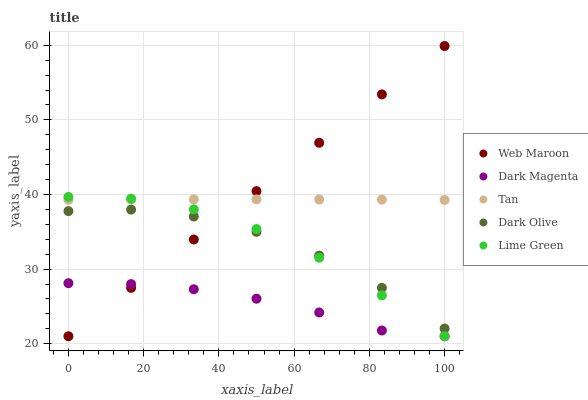Does Dark Magenta have the minimum area under the curve?
Answer yes or no. Yes. Does Web Maroon have the maximum area under the curve?
Answer yes or no. Yes. Does Tan have the minimum area under the curve?
Answer yes or no. No. Does Tan have the maximum area under the curve?
Answer yes or no. No. Is Web Maroon the smoothest?
Answer yes or no. Yes. Is Dark Olive the roughest?
Answer yes or no. Yes. Is Tan the smoothest?
Answer yes or no. No. Is Tan the roughest?
Answer yes or no. No. Does Lime Green have the lowest value?
Answer yes or no. Yes. Does Dark Olive have the lowest value?
Answer yes or no. No. Does Web Maroon have the highest value?
Answer yes or no. Yes. Does Tan have the highest value?
Answer yes or no. No. Is Dark Magenta less than Tan?
Answer yes or no. Yes. Is Tan greater than Dark Magenta?
Answer yes or no. Yes. Does Lime Green intersect Tan?
Answer yes or no. Yes. Is Lime Green less than Tan?
Answer yes or no. No. Is Lime Green greater than Tan?
Answer yes or no. No. Does Dark Magenta intersect Tan?
Answer yes or no. No. 